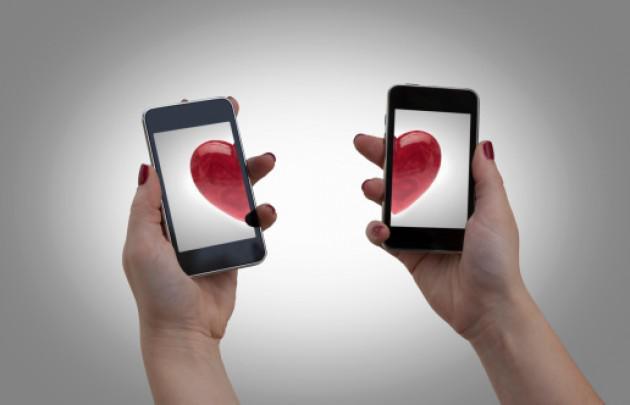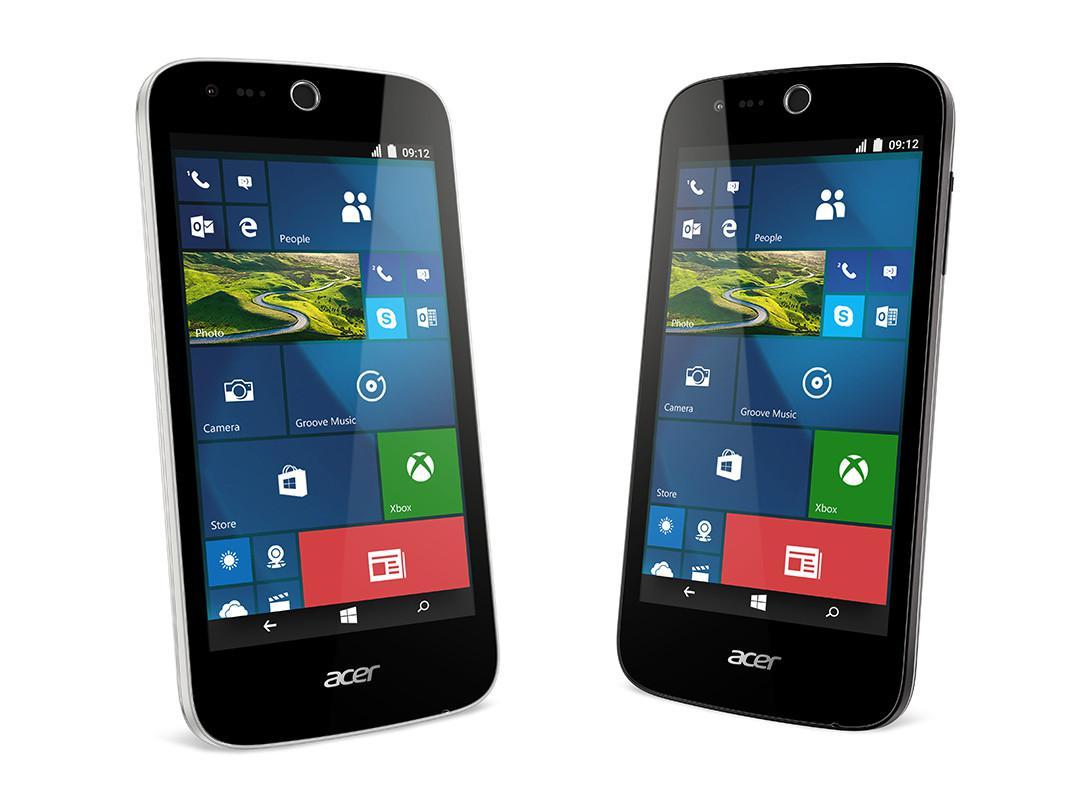The first image is the image on the left, the second image is the image on the right. For the images shown, is this caption "The left image features two palms-up hands, each holding a screen-side up phone next to the other phone." true? Answer yes or no. Yes. The first image is the image on the left, the second image is the image on the right. Evaluate the accuracy of this statement regarding the images: "The left and right image contains a total of four phones.". Is it true? Answer yes or no. Yes. 